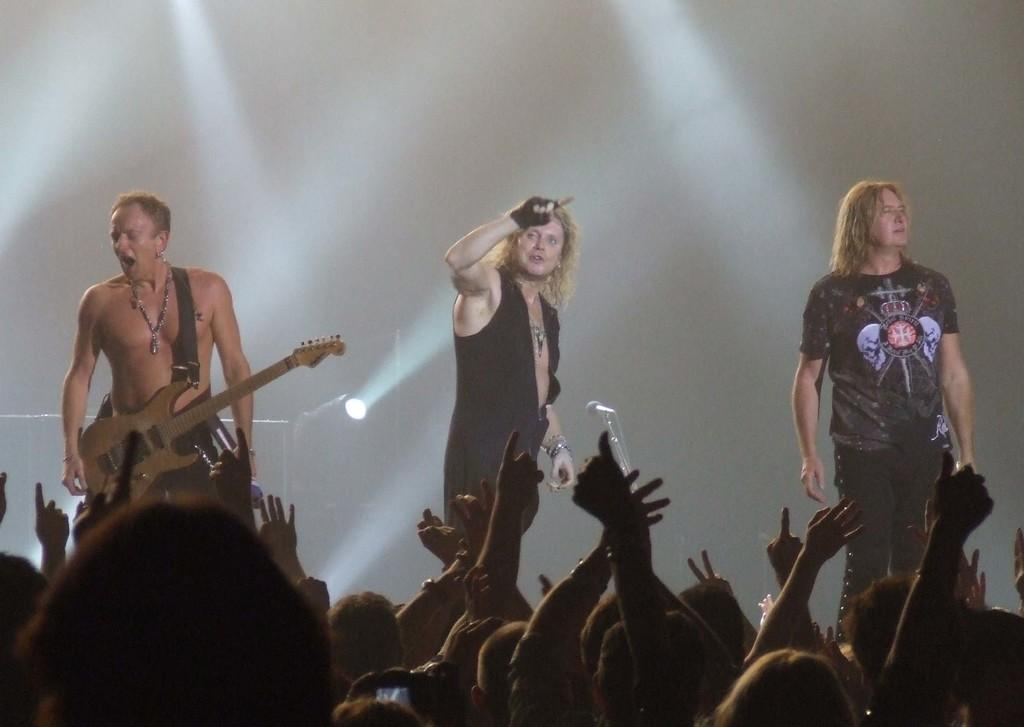How many men are on the stage in the image? There are three men on the stage in the image. What is one of the men doing on the stage? One of the men is wearing a guitar. Can you describe the people in the image? There are people in the image, but their specific actions or appearances are not mentioned in the provided facts. What can be seen in the background of the image? There is light visible in the background. What type of zinc is being used as a prop on the stage? There is no mention of zinc being used as a prop on the stage in the image. Can you describe the chicken that is present on the stage? There is no chicken present on the stage in the image. 